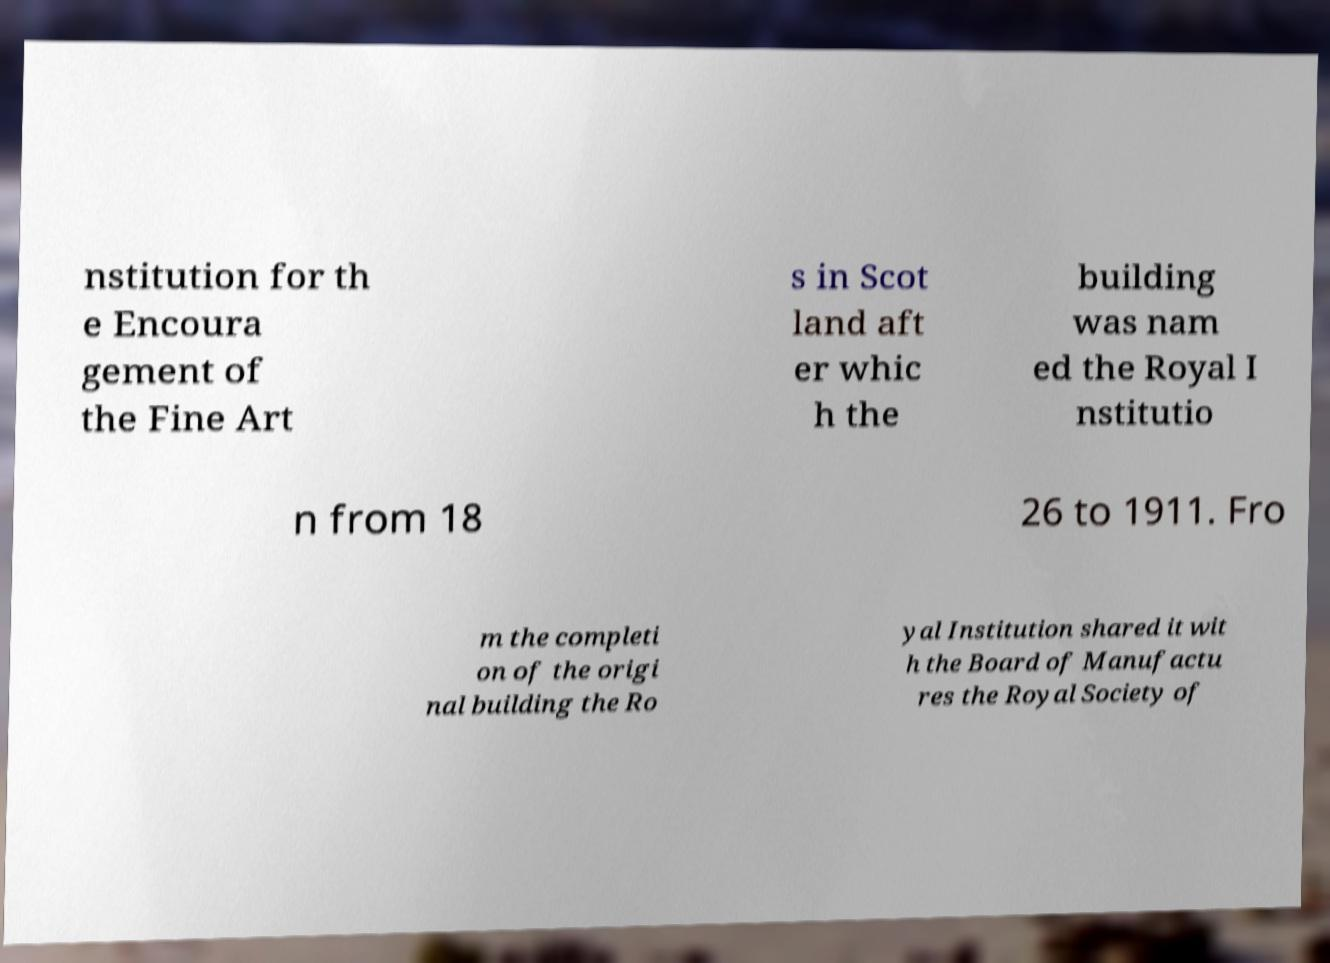Can you accurately transcribe the text from the provided image for me? nstitution for th e Encoura gement of the Fine Art s in Scot land aft er whic h the building was nam ed the Royal I nstitutio n from 18 26 to 1911. Fro m the completi on of the origi nal building the Ro yal Institution shared it wit h the Board of Manufactu res the Royal Society of 